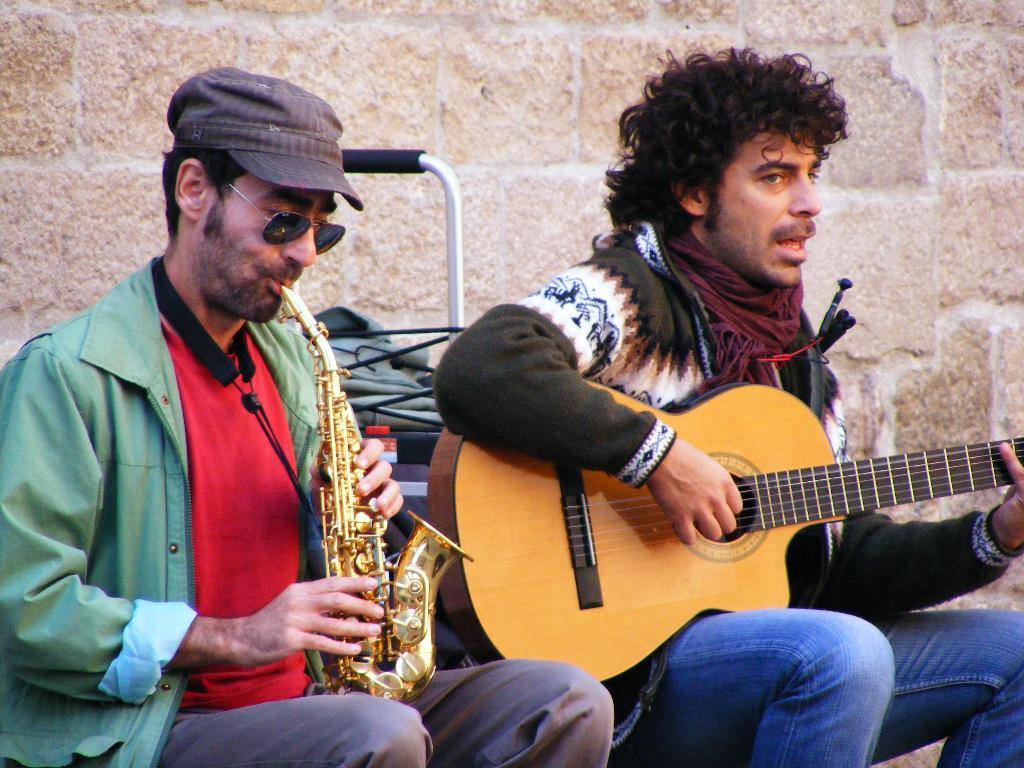How would you summarize this image in a sentence or two? In the image we can see there are two people who are sitting and playing musical instruments. 